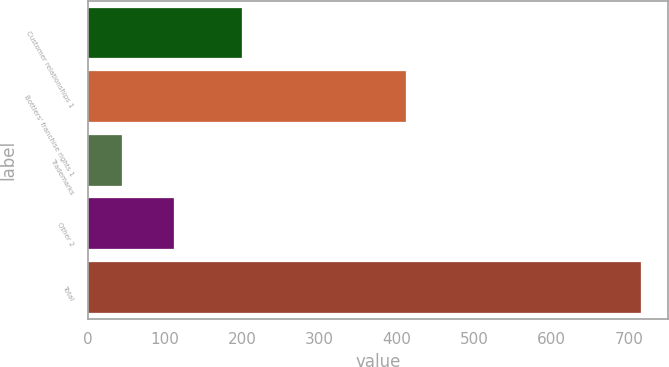Convert chart to OTSL. <chart><loc_0><loc_0><loc_500><loc_500><bar_chart><fcel>Customer relationships 1<fcel>Bottlers' franchise rights 1<fcel>Trademarks<fcel>Other 2<fcel>Total<nl><fcel>199<fcel>412<fcel>44<fcel>111.1<fcel>715<nl></chart> 